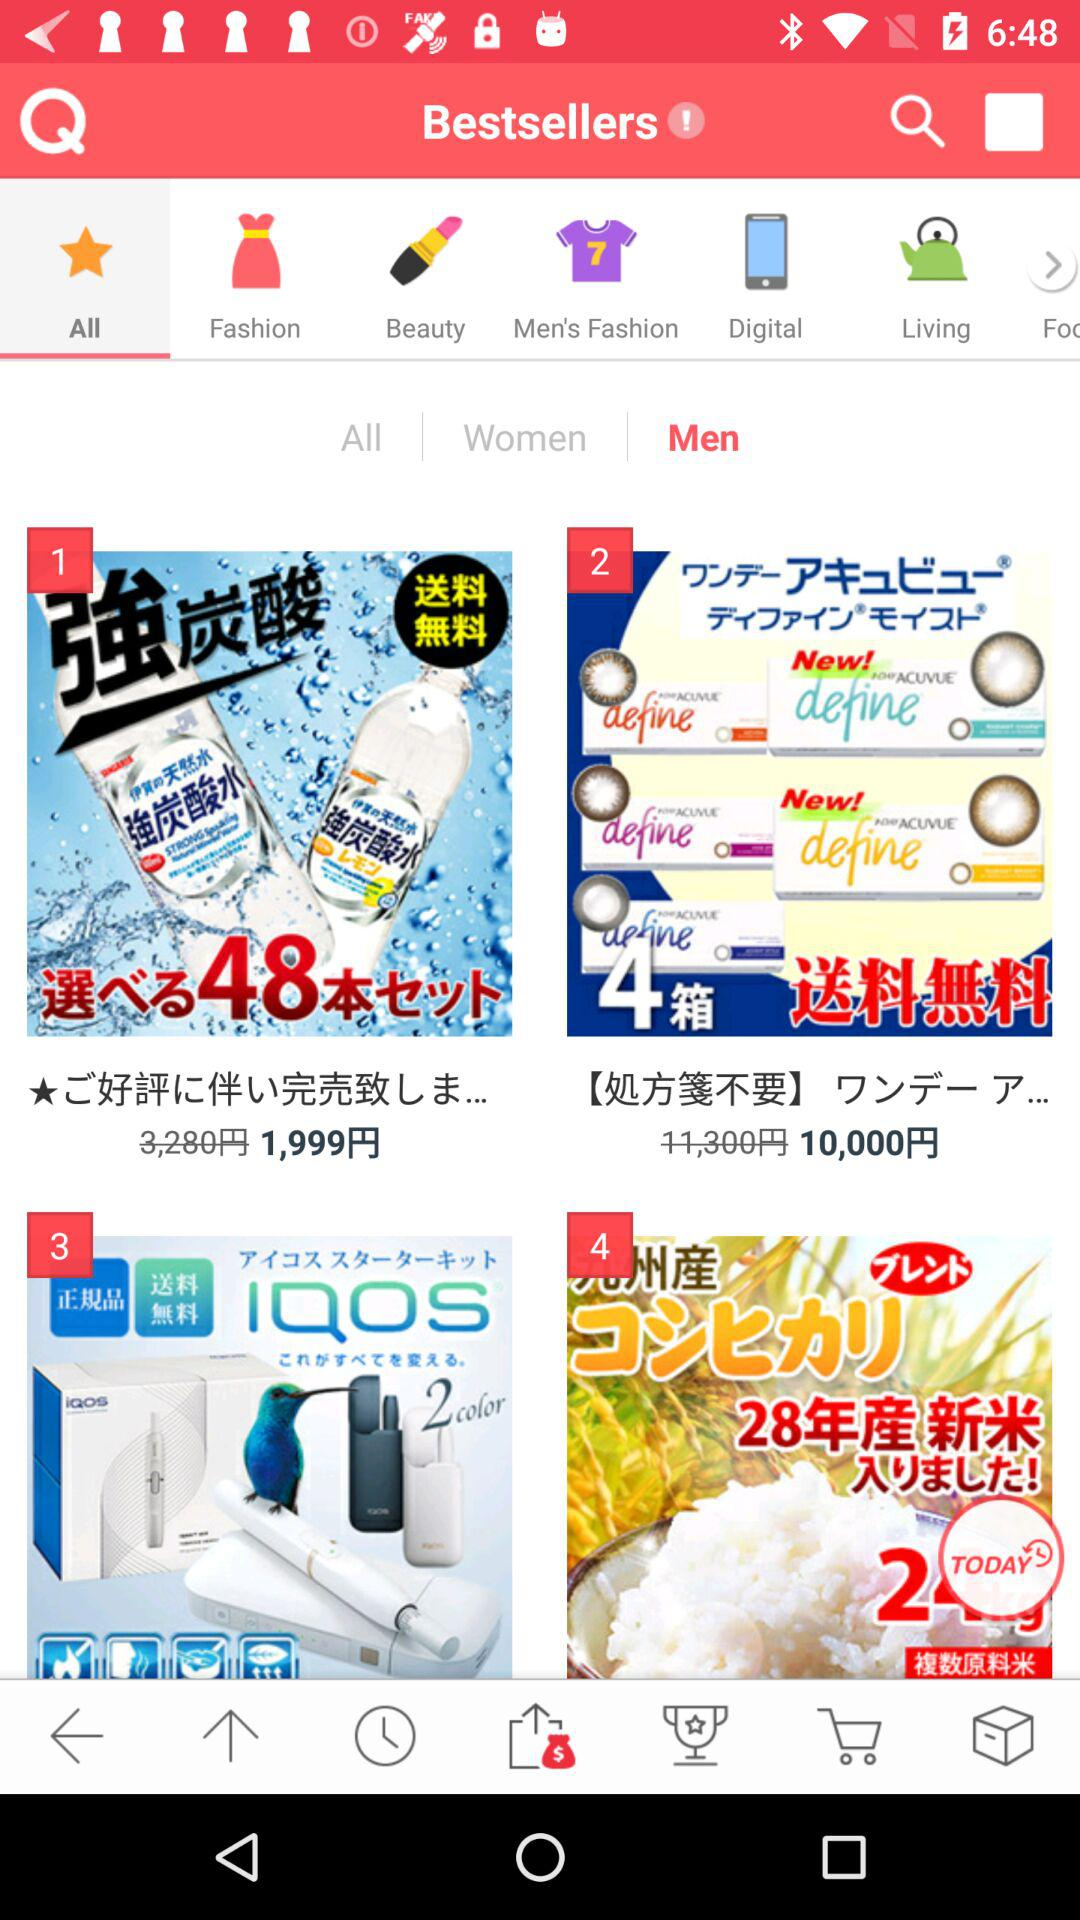Which tab has been selected? The selected tabs are "All" and "Men". 